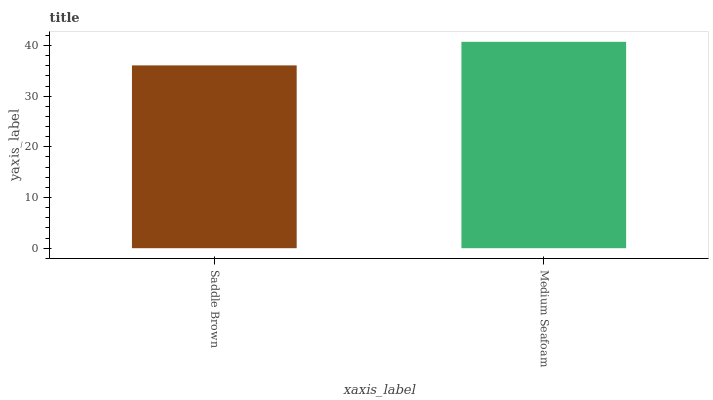Is Saddle Brown the minimum?
Answer yes or no. Yes. Is Medium Seafoam the maximum?
Answer yes or no. Yes. Is Medium Seafoam the minimum?
Answer yes or no. No. Is Medium Seafoam greater than Saddle Brown?
Answer yes or no. Yes. Is Saddle Brown less than Medium Seafoam?
Answer yes or no. Yes. Is Saddle Brown greater than Medium Seafoam?
Answer yes or no. No. Is Medium Seafoam less than Saddle Brown?
Answer yes or no. No. Is Medium Seafoam the high median?
Answer yes or no. Yes. Is Saddle Brown the low median?
Answer yes or no. Yes. Is Saddle Brown the high median?
Answer yes or no. No. Is Medium Seafoam the low median?
Answer yes or no. No. 